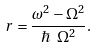Convert formula to latex. <formula><loc_0><loc_0><loc_500><loc_500>r = \frac { \omega ^ { 2 } - \Omega ^ { 2 } } { \hbar { \ } \Omega ^ { 2 } } .</formula> 